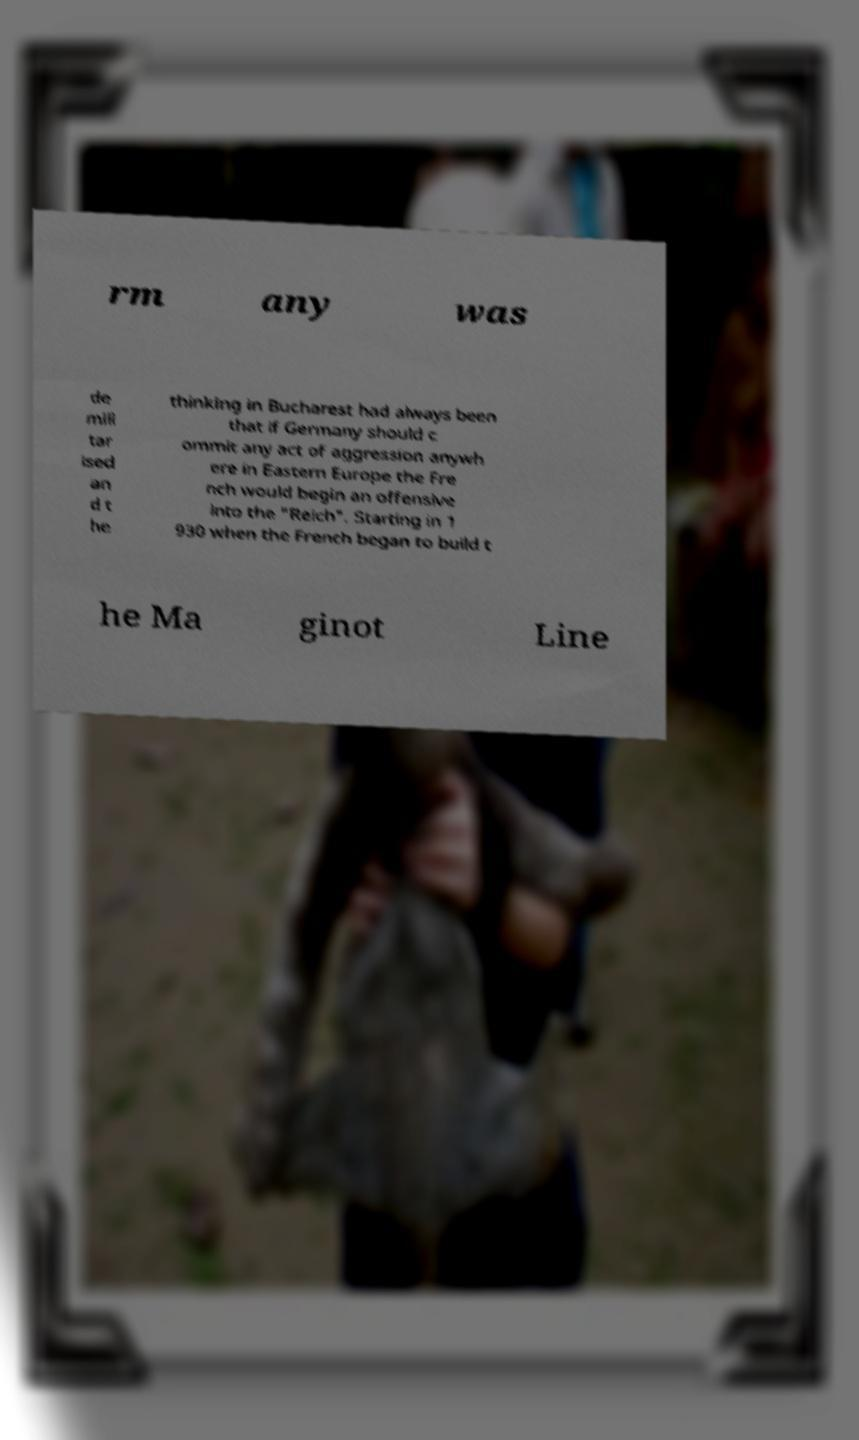Can you read and provide the text displayed in the image?This photo seems to have some interesting text. Can you extract and type it out for me? rm any was de mili tar ised an d t he thinking in Bucharest had always been that if Germany should c ommit any act of aggression anywh ere in Eastern Europe the Fre nch would begin an offensive into the "Reich". Starting in 1 930 when the French began to build t he Ma ginot Line 